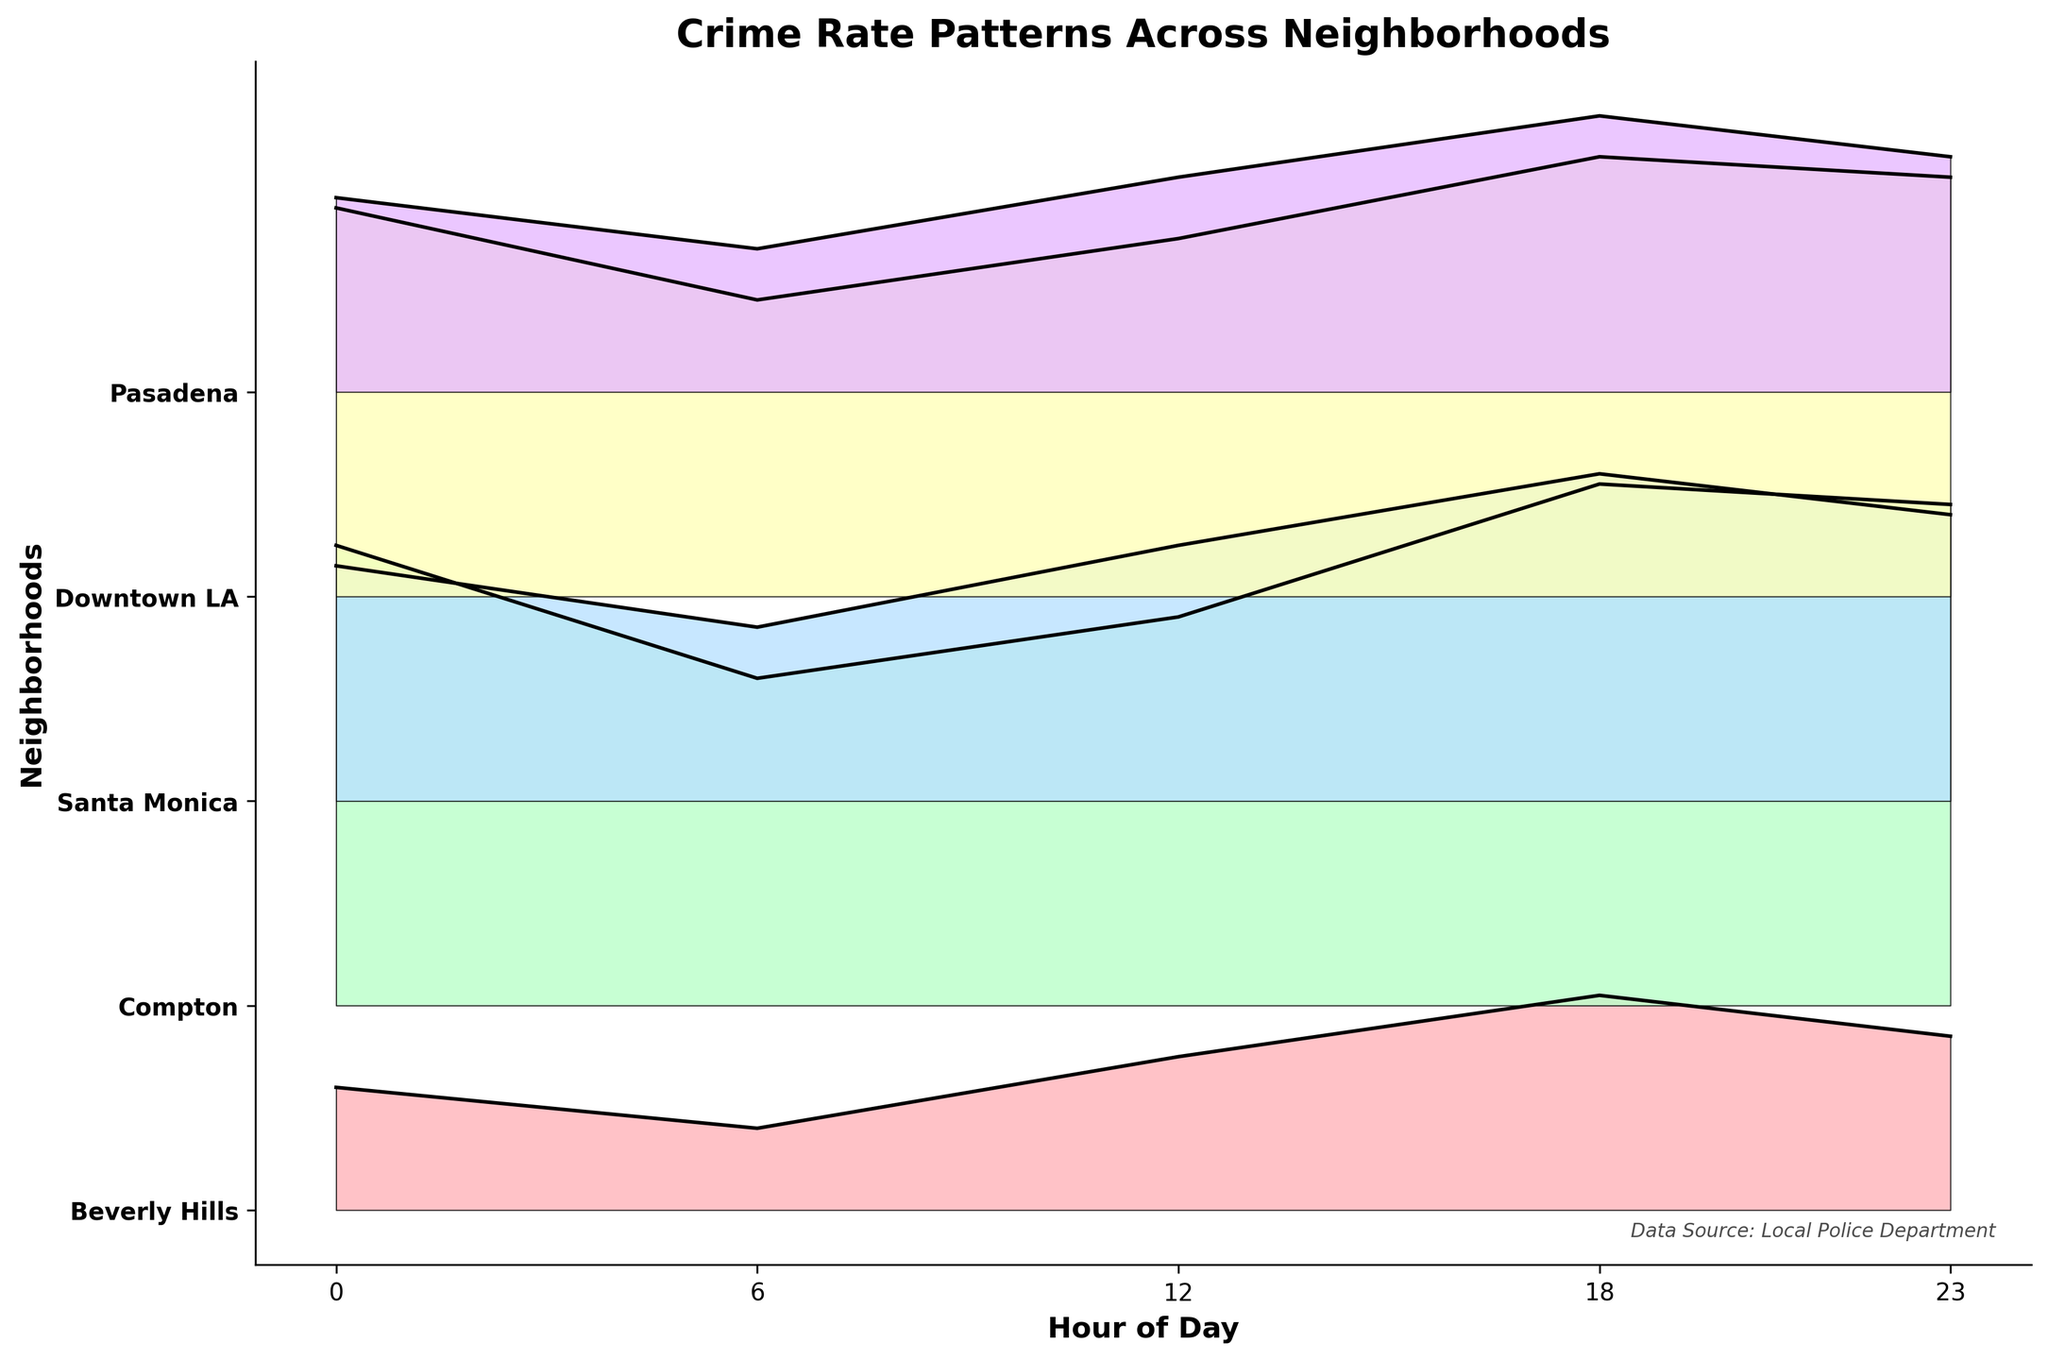What is the title of the figure? The title of the figure is usually located at the top and is formatted in bold. It provides a concise description of the plot's content.
Answer: Crime Rate Patterns Across Neighborhoods What are the labeled axes in the figure? The axes labels give context to what the plot represents. The x-axis is labeled "Hour of Day" and the y-axis is labeled "Neighborhoods."
Answer: Hour of Day; Neighborhoods How many neighborhoods are represented in the plot? By counting the unique labels on the y-axis, we can determine the number of neighborhoods. There are five labeled neighborhoods: Beverly Hills, Compton, Santa Monica, Downtown LA, and Pasadena.
Answer: 5 Which neighborhood has the highest crime rate at 6 AM? Look for the peak on the graph corresponding to the 6 AM time point across all neighborhoods. Compton has the highest crime rate at 6 AM.
Answer: Compton At which hour does Downtown LA experience its peak crime rate? By examining the ridgeline for Downtown LA, identify the hour with the highest peak. The peak for Downtown LA's crime rate occurs at 18 hours.
Answer: 18 hours How does the crime rate in Beverly Hills at 18 hours compare to that at 12 hours? Compare the y-values of the ridgeline plot for Beverly Hills at 12 hours and 18 hours. The crime rate at 18 hours (2.1) is higher than at 12 hours (1.5).
Answer: Higher at 18 hours What is the average crime rate in Santa Monica over all hours? Sum the crime rates for Santa Monica at all time points and divide by the number of time points. (2.3 + 1.7 + 2.5 + 3.2 + 2.8) / 5 = 2.5
Answer: 2.5 Compare the crime rates in Pasadena and Compton at 23 hours. Which has a higher rate? Observe the y-values of the ridgelines at 23 hours for both neighborhoods. Compare the values: Pasadena (2.3) vs. Compton (4.9). Compton has a higher rate.
Answer: Compton Does any neighborhood show a decrease in crime rate from 0 hours to 6 hours? Check the crime rates at 0 hours and 6 hours for all neighborhoods and compare. For Beverly Hills, the crime rate decreases from 1.2 to 0.8 from 0 hours to 6 hours.
Answer: Beverly Hills Which neighborhood has the most uniform crime rate throughout the day? By examining the ridgelines, look for the neighborhood with the least variation in the y-axis values across all hours. Pasadena has fairly consistent crime rates, indicating a relatively uniform crime rate.
Answer: Pasadena 